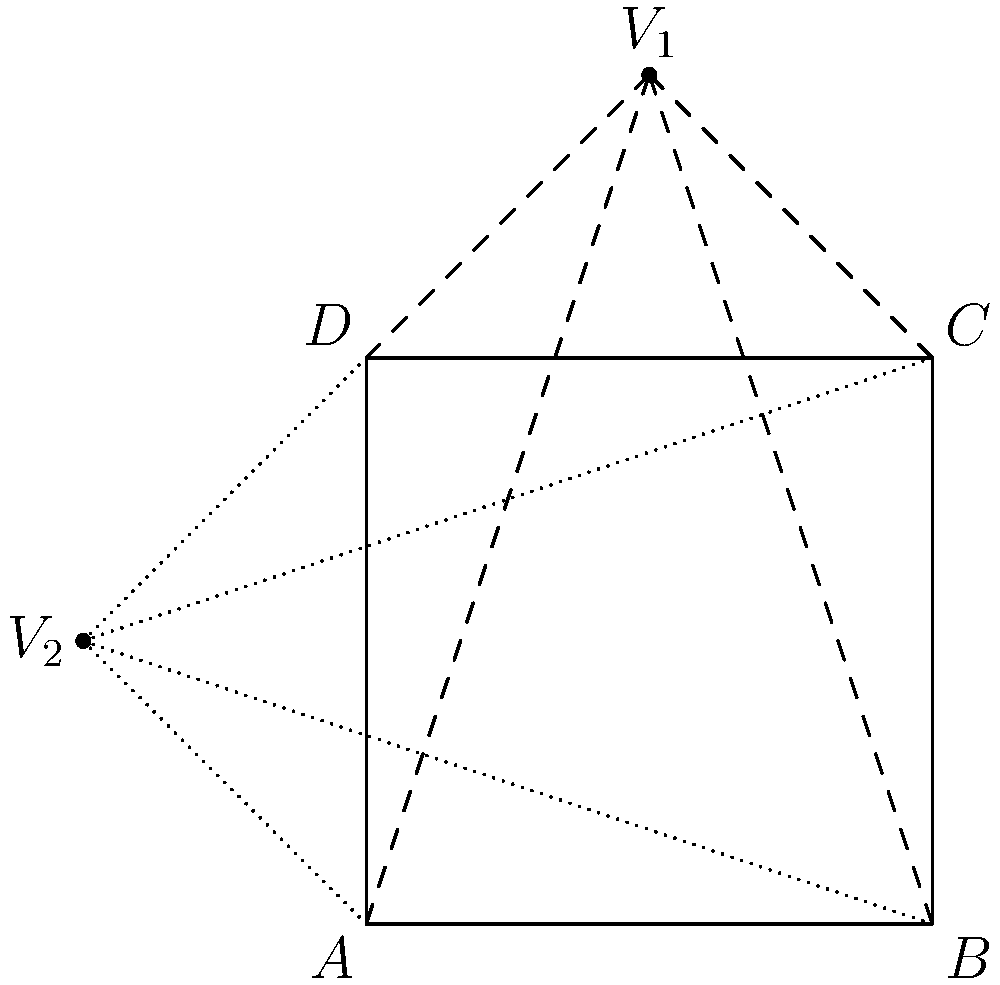In the diagram, a square $ABCD$ is depicted with two vanishing points $V_1$ and $V_2$. If the square represents a film frame, and the vanishing points represent different camera angles, what artistic effect is achieved by positioning $V_1$ above the frame and $V_2$ to the left of the frame? To understand the artistic effect, let's analyze the perspective created by each vanishing point:

1. Vanishing point $V_1$ (above the frame):
   - Creates vertical lines converging upwards
   - Suggests a low-angle shot or "worm's-eye view"
   - Emphasizes height and can make subjects appear more imposing or powerful

2. Vanishing point $V_2$ (left of the frame):
   - Creates horizontal lines converging to the left
   - Suggests a rightward movement or direction in the scene
   - Can create a sense of depth or forward motion

3. Combined effect:
   - The dual vanishing points create a dynamic, skewed perspective
   - This combination suggests both vertical exaggeration and horizontal motion
   - It results in a diagonally-oriented composition, adding visual tension and energy

4. Artistic implications:
   - Creates a sense of unease or disorientation in the viewer
   - Emphasizes the three-dimensionality of the space within a two-dimensional frame
   - Can be used to convey subjective experiences or altered states of perception

5. In avant-garde filmmaking:
   - Challenges traditional framing and composition rules
   - Encourages viewers to question their perception of space and reality
   - Can be used to represent complex emotional or psychological states

The overall artistic effect achieved is a heightened sense of drama, dynamism, and psychological intensity, which aligns well with avant-garde filmmaking techniques that aim to challenge conventional visual storytelling.
Answer: Dynamic, skewed perspective creating visual tension and psychological intensity 